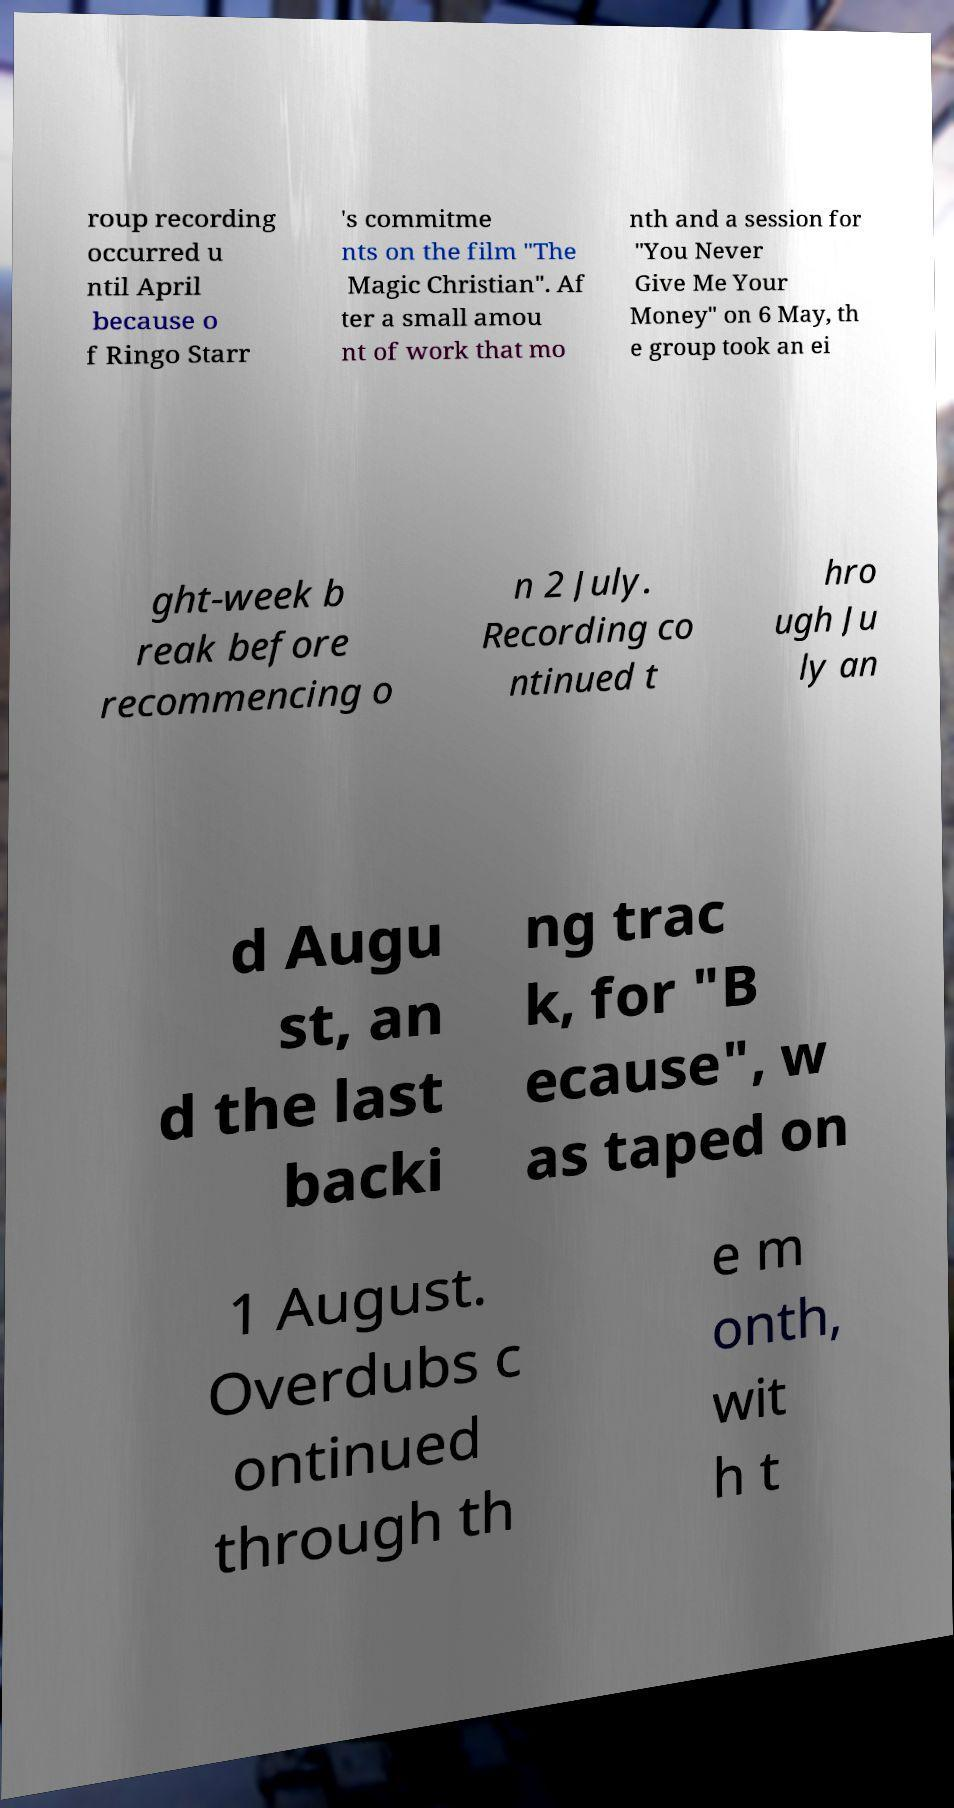What messages or text are displayed in this image? I need them in a readable, typed format. roup recording occurred u ntil April because o f Ringo Starr 's commitme nts on the film "The Magic Christian". Af ter a small amou nt of work that mo nth and a session for "You Never Give Me Your Money" on 6 May, th e group took an ei ght-week b reak before recommencing o n 2 July. Recording co ntinued t hro ugh Ju ly an d Augu st, an d the last backi ng trac k, for "B ecause", w as taped on 1 August. Overdubs c ontinued through th e m onth, wit h t 